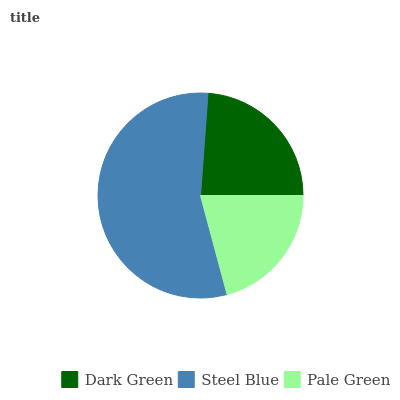Is Pale Green the minimum?
Answer yes or no. Yes. Is Steel Blue the maximum?
Answer yes or no. Yes. Is Steel Blue the minimum?
Answer yes or no. No. Is Pale Green the maximum?
Answer yes or no. No. Is Steel Blue greater than Pale Green?
Answer yes or no. Yes. Is Pale Green less than Steel Blue?
Answer yes or no. Yes. Is Pale Green greater than Steel Blue?
Answer yes or no. No. Is Steel Blue less than Pale Green?
Answer yes or no. No. Is Dark Green the high median?
Answer yes or no. Yes. Is Dark Green the low median?
Answer yes or no. Yes. Is Steel Blue the high median?
Answer yes or no. No. Is Steel Blue the low median?
Answer yes or no. No. 